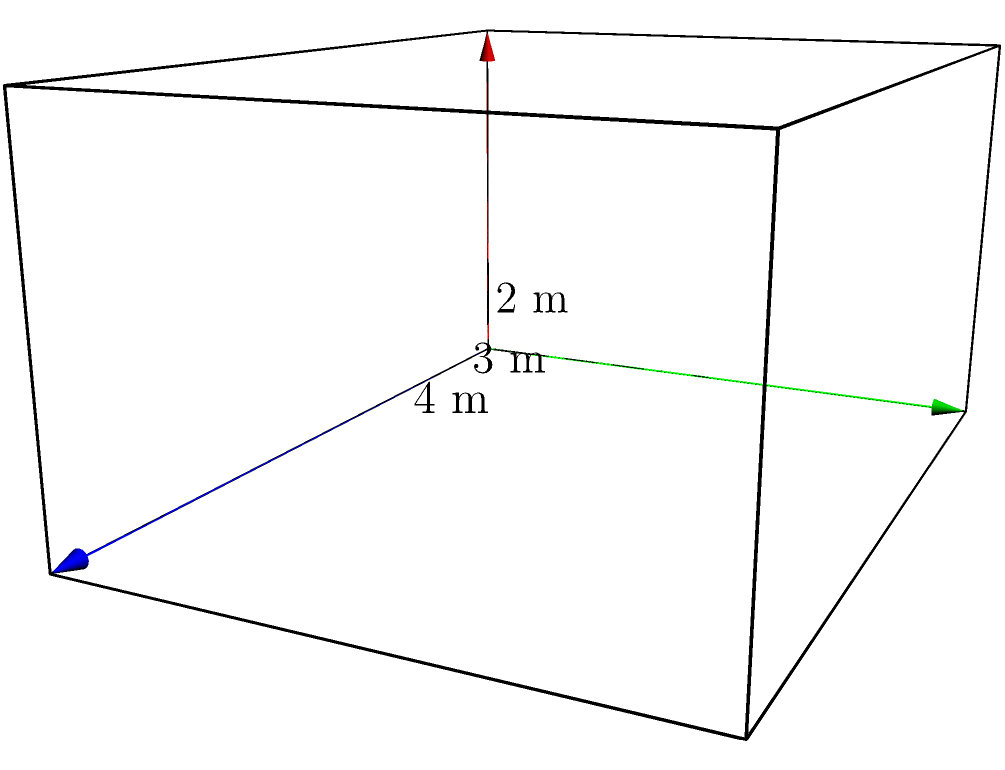As a performance anxiety specialist, you often use metaphors to help musicians visualize their anxiety. Imagine a rectangular prism representing a musician's potential performance space on stage. If the length of the stage is 4 meters, the width is 3 meters, and the height (representing the musician's reach) is 2 meters, what is the volume of this performance space? How might understanding this "space" help a musician manage their stage fright? To calculate the volume of a rectangular prism, we use the formula:

$$V = l \times w \times h$$

Where:
$V$ = volume
$l$ = length
$w$ = width
$h$ = height

Given:
$l = 4$ meters
$w = 3$ meters
$h = 2$ meters

Let's substitute these values into the formula:

$$V = 4 \times 3 \times 2$$

$$V = 24$$

Therefore, the volume of the rectangular prism (performance space) is 24 cubic meters.

Understanding this "space" can help a musician manage their stage fright in several ways:

1. Spatial awareness: Knowing the exact dimensions of their performance area can help musicians feel more in control of their environment.

2. Breathing visualization: Musicians can imagine filling this space with their breath, promoting relaxation and focus.

3. Sound projection: Visualizing their sound filling this volume can boost confidence in their ability to reach the audience.

4. Movement planning: Understanding the available space can help plan stage movements, reducing anxiety about physical aspects of the performance.

5. Grounding technique: The concrete dimensions provide a tangible focus point, helping to anchor the musician in the present moment rather than anxiety about the future.
Answer: 24 cubic meters 